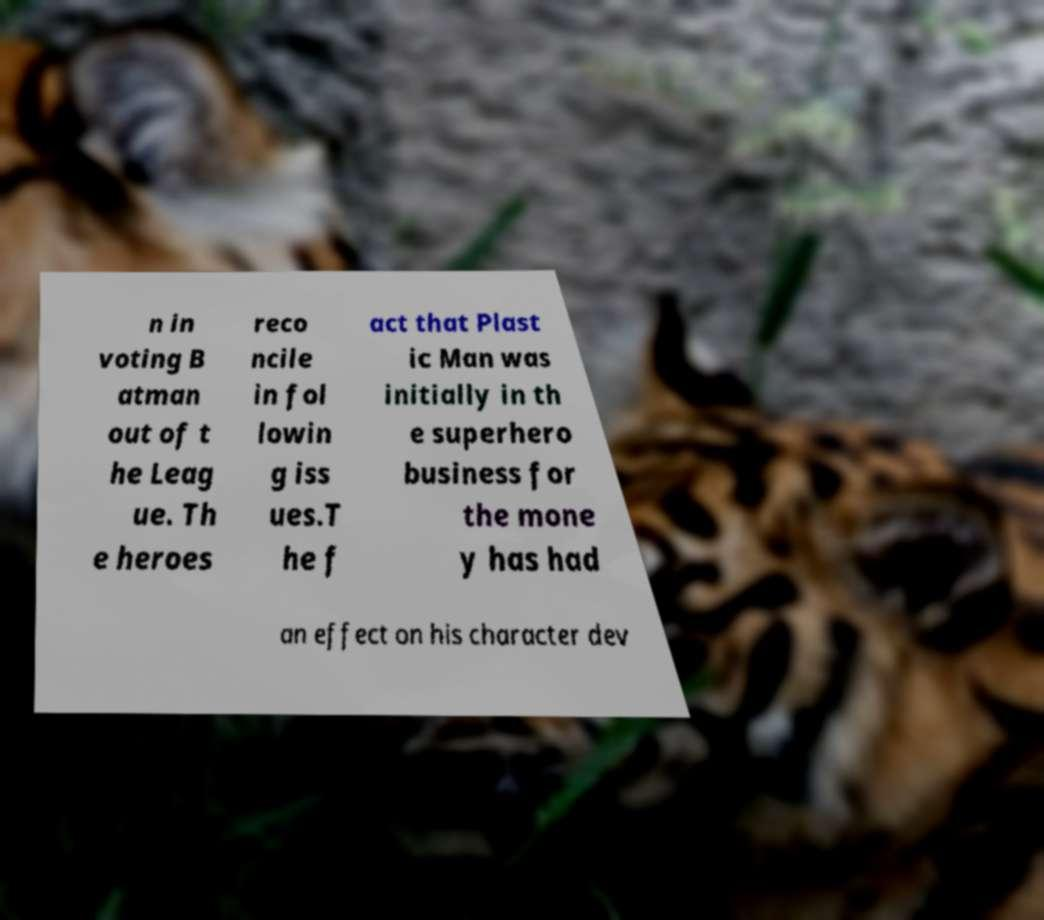Please read and relay the text visible in this image. What does it say? n in voting B atman out of t he Leag ue. Th e heroes reco ncile in fol lowin g iss ues.T he f act that Plast ic Man was initially in th e superhero business for the mone y has had an effect on his character dev 